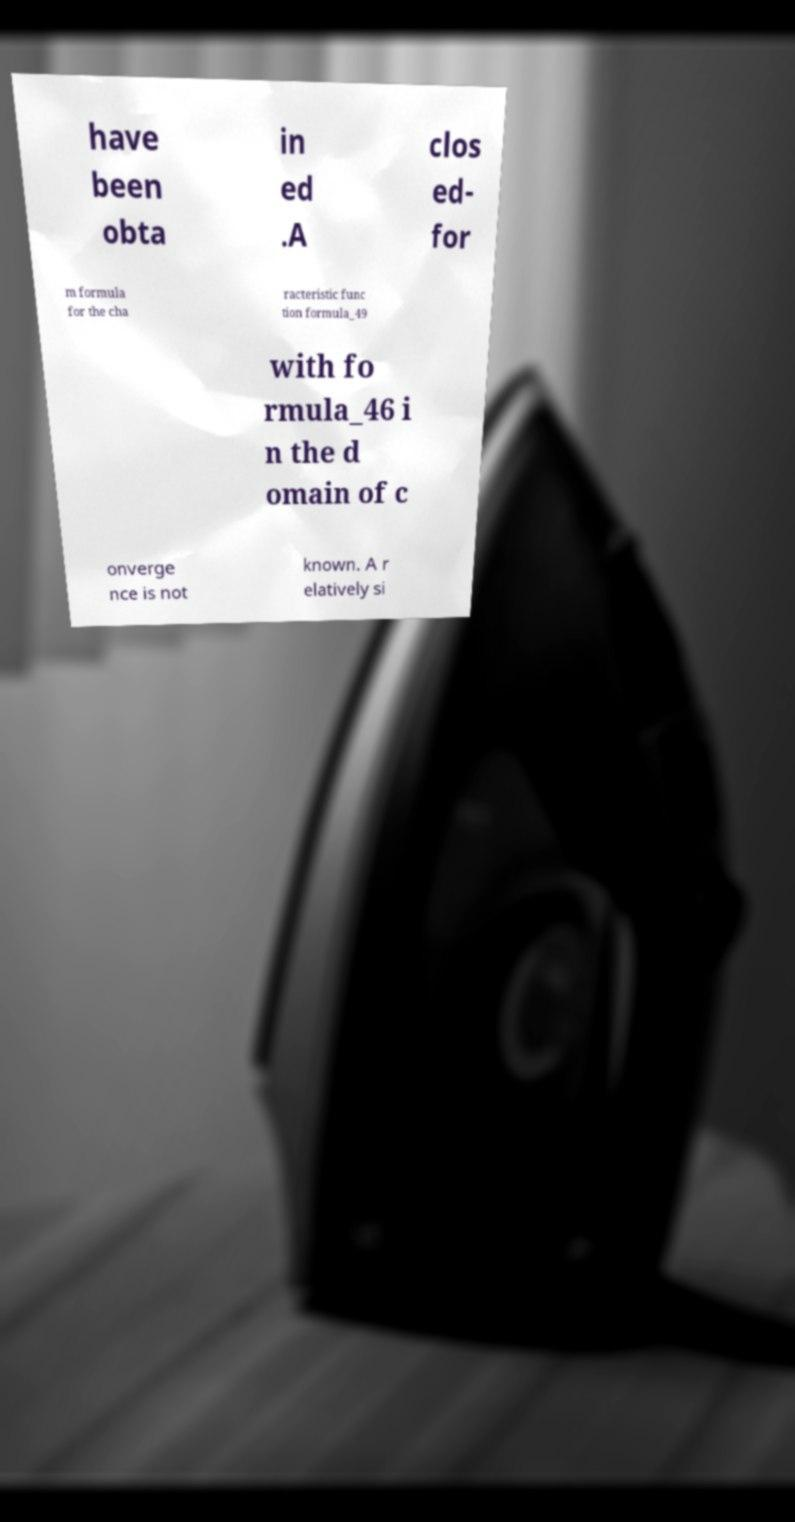Could you assist in decoding the text presented in this image and type it out clearly? have been obta in ed .A clos ed- for m formula for the cha racteristic func tion formula_49 with fo rmula_46 i n the d omain of c onverge nce is not known. A r elatively si 